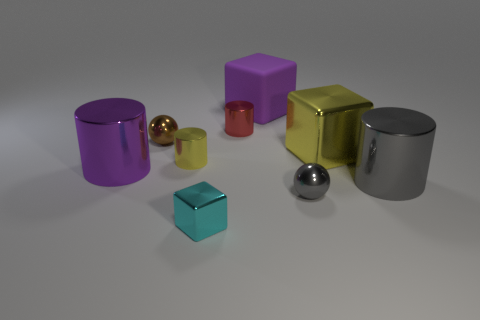Subtract all small red metallic cylinders. How many cylinders are left? 3 Subtract 1 cubes. How many cubes are left? 2 Subtract all yellow cylinders. How many cylinders are left? 3 Add 1 small red objects. How many objects exist? 10 Subtract all cylinders. How many objects are left? 5 Subtract all brown cylinders. Subtract all cyan spheres. How many cylinders are left? 4 Add 8 yellow objects. How many yellow objects are left? 10 Add 6 cyan metal blocks. How many cyan metal blocks exist? 7 Subtract 0 blue blocks. How many objects are left? 9 Subtract all yellow things. Subtract all tiny cyan objects. How many objects are left? 6 